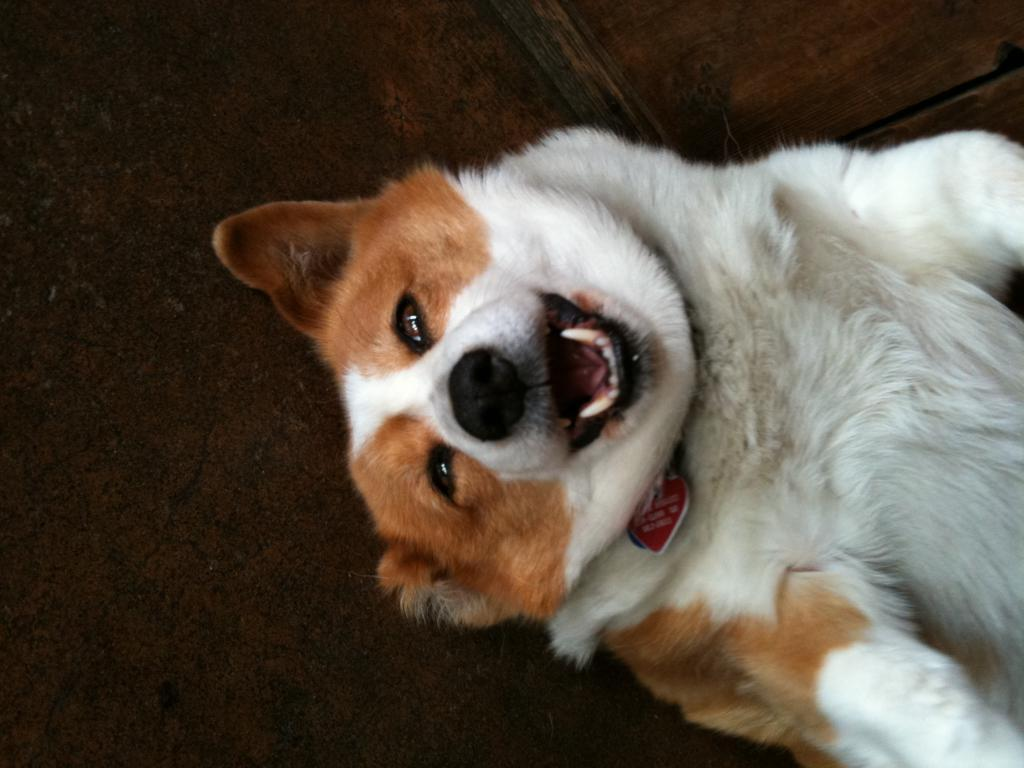What type of animal is in the image? There is a dog in the image. What is the dog wearing? The dog is wearing a belt with a locket. What is the dog's position in the image? The dog is lying on a surface. What can be seen in the top right of the image? There is a wooden object in the top right of the image. How does the dog use its arm to control the stick in the image? There is no stick present in the image, and dogs do not have arms to control objects. 